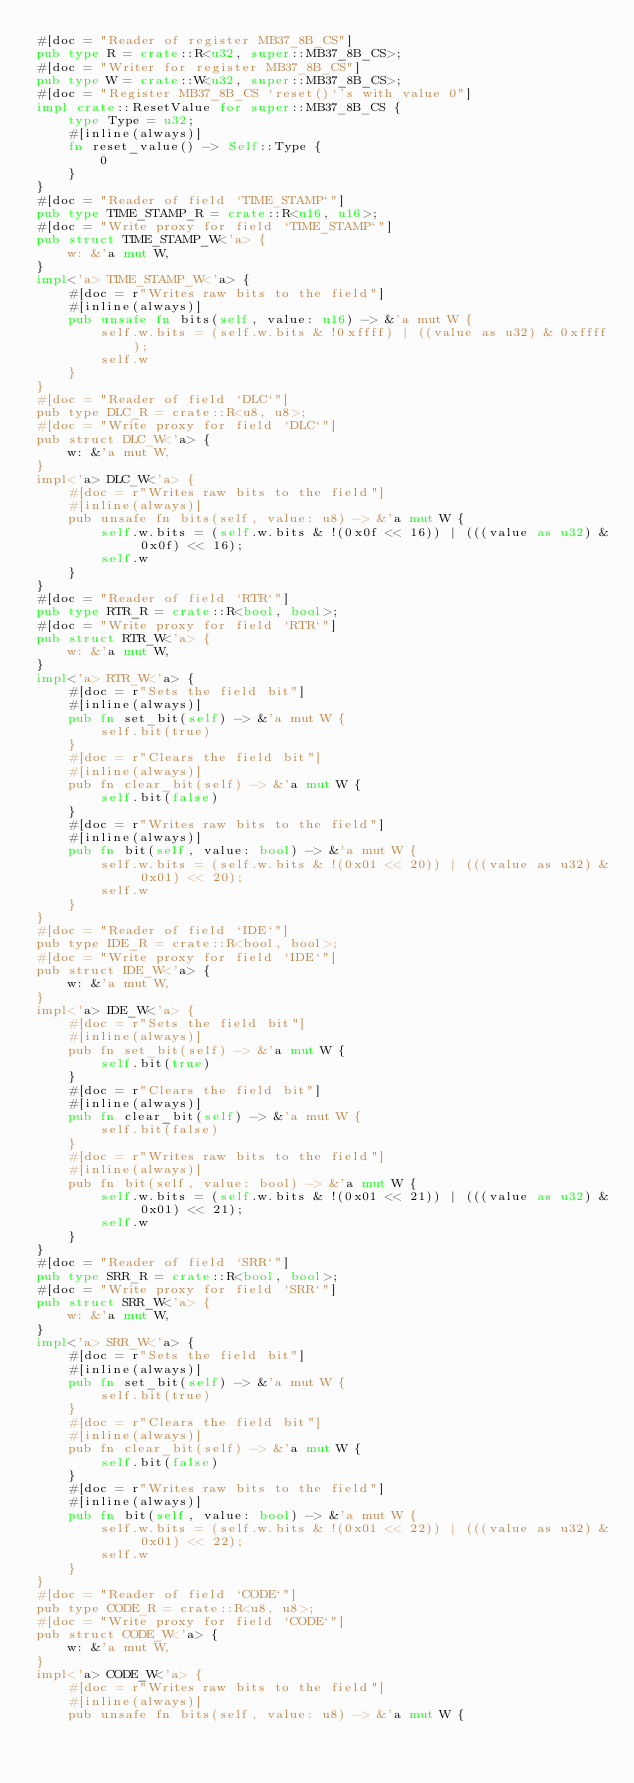Convert code to text. <code><loc_0><loc_0><loc_500><loc_500><_Rust_>#[doc = "Reader of register MB37_8B_CS"]
pub type R = crate::R<u32, super::MB37_8B_CS>;
#[doc = "Writer for register MB37_8B_CS"]
pub type W = crate::W<u32, super::MB37_8B_CS>;
#[doc = "Register MB37_8B_CS `reset()`'s with value 0"]
impl crate::ResetValue for super::MB37_8B_CS {
    type Type = u32;
    #[inline(always)]
    fn reset_value() -> Self::Type {
        0
    }
}
#[doc = "Reader of field `TIME_STAMP`"]
pub type TIME_STAMP_R = crate::R<u16, u16>;
#[doc = "Write proxy for field `TIME_STAMP`"]
pub struct TIME_STAMP_W<'a> {
    w: &'a mut W,
}
impl<'a> TIME_STAMP_W<'a> {
    #[doc = r"Writes raw bits to the field"]
    #[inline(always)]
    pub unsafe fn bits(self, value: u16) -> &'a mut W {
        self.w.bits = (self.w.bits & !0xffff) | ((value as u32) & 0xffff);
        self.w
    }
}
#[doc = "Reader of field `DLC`"]
pub type DLC_R = crate::R<u8, u8>;
#[doc = "Write proxy for field `DLC`"]
pub struct DLC_W<'a> {
    w: &'a mut W,
}
impl<'a> DLC_W<'a> {
    #[doc = r"Writes raw bits to the field"]
    #[inline(always)]
    pub unsafe fn bits(self, value: u8) -> &'a mut W {
        self.w.bits = (self.w.bits & !(0x0f << 16)) | (((value as u32) & 0x0f) << 16);
        self.w
    }
}
#[doc = "Reader of field `RTR`"]
pub type RTR_R = crate::R<bool, bool>;
#[doc = "Write proxy for field `RTR`"]
pub struct RTR_W<'a> {
    w: &'a mut W,
}
impl<'a> RTR_W<'a> {
    #[doc = r"Sets the field bit"]
    #[inline(always)]
    pub fn set_bit(self) -> &'a mut W {
        self.bit(true)
    }
    #[doc = r"Clears the field bit"]
    #[inline(always)]
    pub fn clear_bit(self) -> &'a mut W {
        self.bit(false)
    }
    #[doc = r"Writes raw bits to the field"]
    #[inline(always)]
    pub fn bit(self, value: bool) -> &'a mut W {
        self.w.bits = (self.w.bits & !(0x01 << 20)) | (((value as u32) & 0x01) << 20);
        self.w
    }
}
#[doc = "Reader of field `IDE`"]
pub type IDE_R = crate::R<bool, bool>;
#[doc = "Write proxy for field `IDE`"]
pub struct IDE_W<'a> {
    w: &'a mut W,
}
impl<'a> IDE_W<'a> {
    #[doc = r"Sets the field bit"]
    #[inline(always)]
    pub fn set_bit(self) -> &'a mut W {
        self.bit(true)
    }
    #[doc = r"Clears the field bit"]
    #[inline(always)]
    pub fn clear_bit(self) -> &'a mut W {
        self.bit(false)
    }
    #[doc = r"Writes raw bits to the field"]
    #[inline(always)]
    pub fn bit(self, value: bool) -> &'a mut W {
        self.w.bits = (self.w.bits & !(0x01 << 21)) | (((value as u32) & 0x01) << 21);
        self.w
    }
}
#[doc = "Reader of field `SRR`"]
pub type SRR_R = crate::R<bool, bool>;
#[doc = "Write proxy for field `SRR`"]
pub struct SRR_W<'a> {
    w: &'a mut W,
}
impl<'a> SRR_W<'a> {
    #[doc = r"Sets the field bit"]
    #[inline(always)]
    pub fn set_bit(self) -> &'a mut W {
        self.bit(true)
    }
    #[doc = r"Clears the field bit"]
    #[inline(always)]
    pub fn clear_bit(self) -> &'a mut W {
        self.bit(false)
    }
    #[doc = r"Writes raw bits to the field"]
    #[inline(always)]
    pub fn bit(self, value: bool) -> &'a mut W {
        self.w.bits = (self.w.bits & !(0x01 << 22)) | (((value as u32) & 0x01) << 22);
        self.w
    }
}
#[doc = "Reader of field `CODE`"]
pub type CODE_R = crate::R<u8, u8>;
#[doc = "Write proxy for field `CODE`"]
pub struct CODE_W<'a> {
    w: &'a mut W,
}
impl<'a> CODE_W<'a> {
    #[doc = r"Writes raw bits to the field"]
    #[inline(always)]
    pub unsafe fn bits(self, value: u8) -> &'a mut W {</code> 